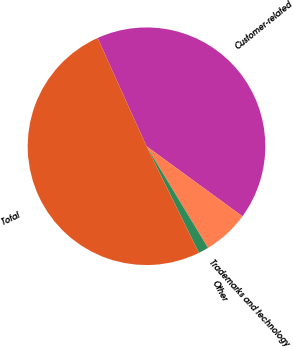Convert chart to OTSL. <chart><loc_0><loc_0><loc_500><loc_500><pie_chart><fcel>Customer-related<fcel>Trademarks and technology<fcel>Other<fcel>Total<nl><fcel>41.79%<fcel>6.3%<fcel>1.39%<fcel>50.52%<nl></chart> 